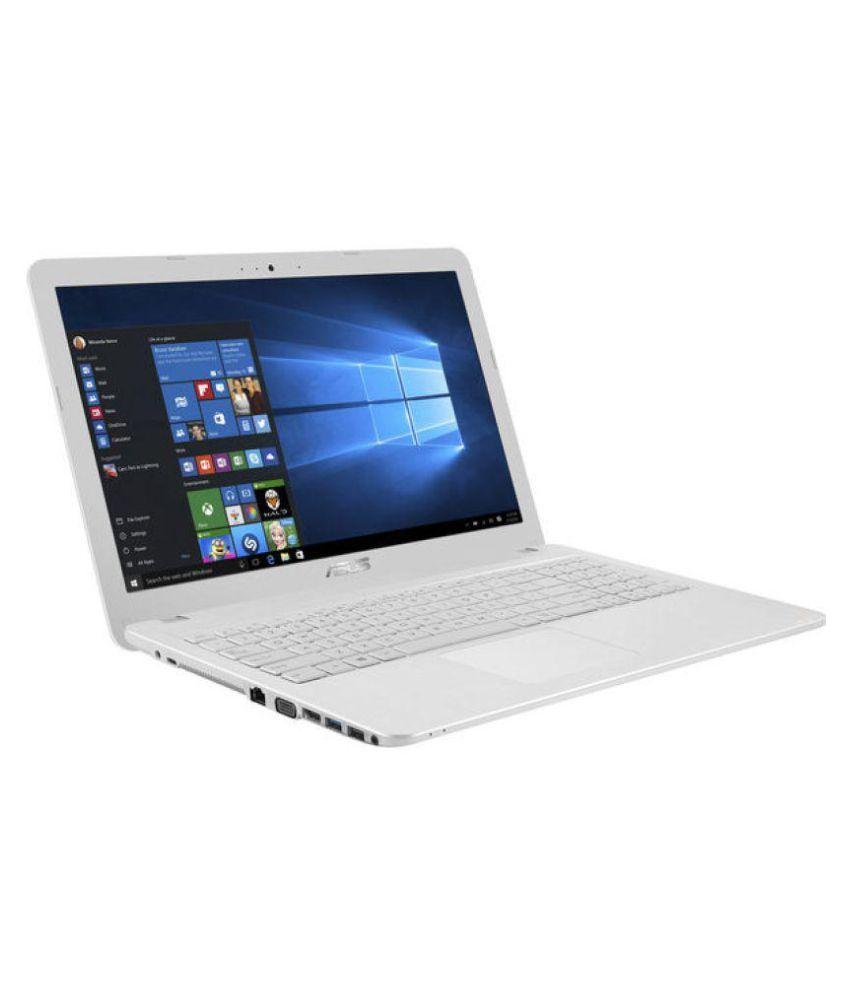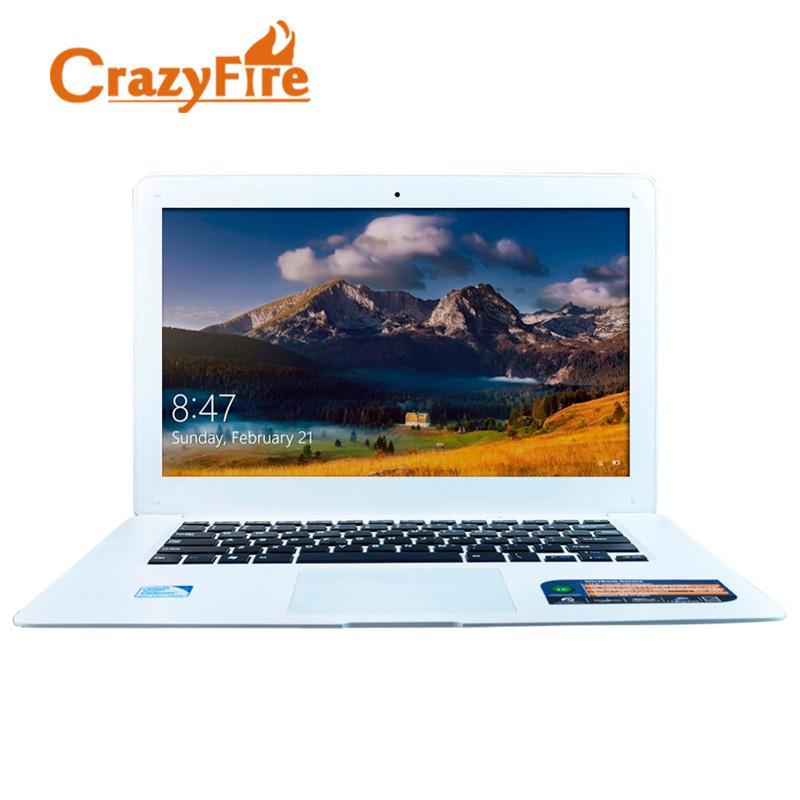The first image is the image on the left, the second image is the image on the right. Assess this claim about the two images: "One fully open laptop computer is black, and a second laptop is a different color.". Correct or not? Answer yes or no. No. The first image is the image on the left, the second image is the image on the right. For the images shown, is this caption "There is a black laptop to the left of a lighter colored laptop" true? Answer yes or no. No. 